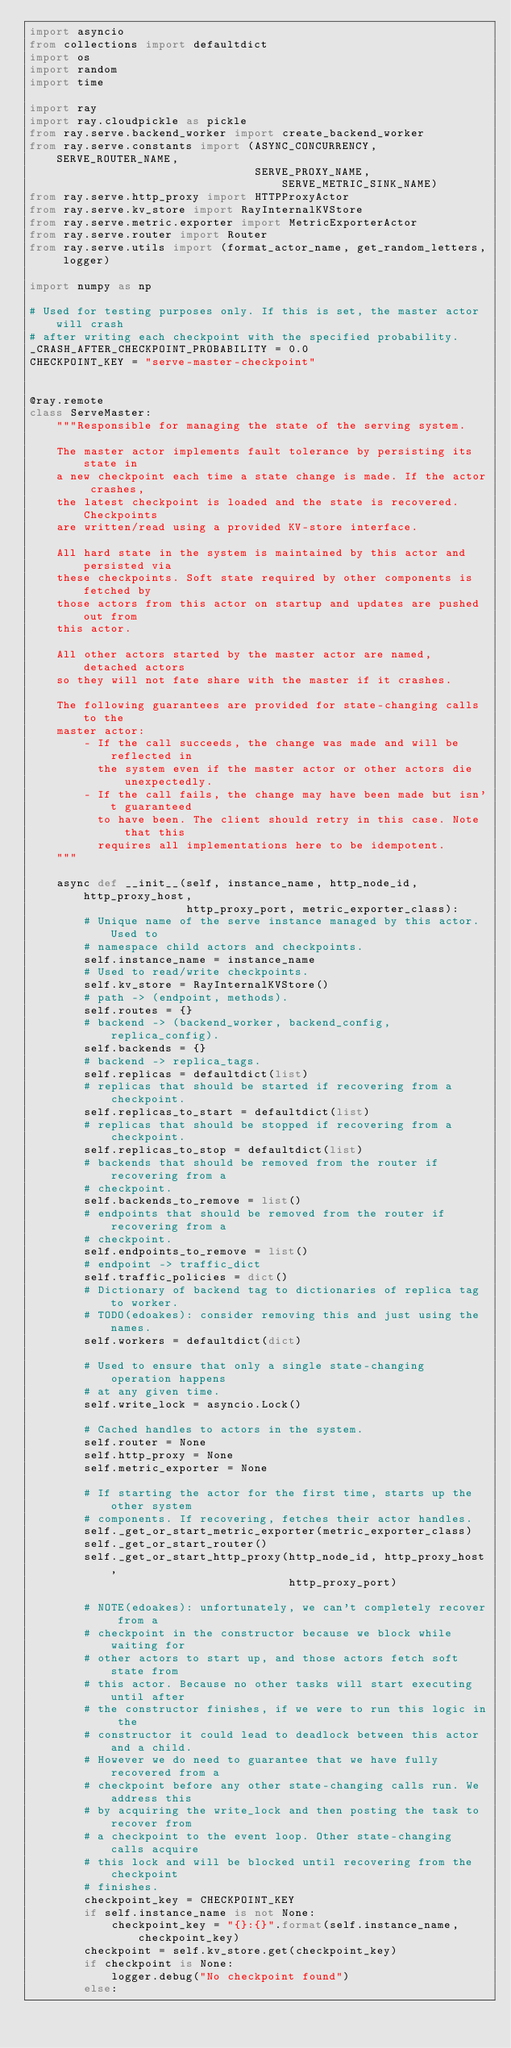Convert code to text. <code><loc_0><loc_0><loc_500><loc_500><_Python_>import asyncio
from collections import defaultdict
import os
import random
import time

import ray
import ray.cloudpickle as pickle
from ray.serve.backend_worker import create_backend_worker
from ray.serve.constants import (ASYNC_CONCURRENCY, SERVE_ROUTER_NAME,
                                 SERVE_PROXY_NAME, SERVE_METRIC_SINK_NAME)
from ray.serve.http_proxy import HTTPProxyActor
from ray.serve.kv_store import RayInternalKVStore
from ray.serve.metric.exporter import MetricExporterActor
from ray.serve.router import Router
from ray.serve.utils import (format_actor_name, get_random_letters, logger)

import numpy as np

# Used for testing purposes only. If this is set, the master actor will crash
# after writing each checkpoint with the specified probability.
_CRASH_AFTER_CHECKPOINT_PROBABILITY = 0.0
CHECKPOINT_KEY = "serve-master-checkpoint"


@ray.remote
class ServeMaster:
    """Responsible for managing the state of the serving system.

    The master actor implements fault tolerance by persisting its state in
    a new checkpoint each time a state change is made. If the actor crashes,
    the latest checkpoint is loaded and the state is recovered. Checkpoints
    are written/read using a provided KV-store interface.

    All hard state in the system is maintained by this actor and persisted via
    these checkpoints. Soft state required by other components is fetched by
    those actors from this actor on startup and updates are pushed out from
    this actor.

    All other actors started by the master actor are named, detached actors
    so they will not fate share with the master if it crashes.

    The following guarantees are provided for state-changing calls to the
    master actor:
        - If the call succeeds, the change was made and will be reflected in
          the system even if the master actor or other actors die unexpectedly.
        - If the call fails, the change may have been made but isn't guaranteed
          to have been. The client should retry in this case. Note that this
          requires all implementations here to be idempotent.
    """

    async def __init__(self, instance_name, http_node_id, http_proxy_host,
                       http_proxy_port, metric_exporter_class):
        # Unique name of the serve instance managed by this actor. Used to
        # namespace child actors and checkpoints.
        self.instance_name = instance_name
        # Used to read/write checkpoints.
        self.kv_store = RayInternalKVStore()
        # path -> (endpoint, methods).
        self.routes = {}
        # backend -> (backend_worker, backend_config, replica_config).
        self.backends = {}
        # backend -> replica_tags.
        self.replicas = defaultdict(list)
        # replicas that should be started if recovering from a checkpoint.
        self.replicas_to_start = defaultdict(list)
        # replicas that should be stopped if recovering from a checkpoint.
        self.replicas_to_stop = defaultdict(list)
        # backends that should be removed from the router if recovering from a
        # checkpoint.
        self.backends_to_remove = list()
        # endpoints that should be removed from the router if recovering from a
        # checkpoint.
        self.endpoints_to_remove = list()
        # endpoint -> traffic_dict
        self.traffic_policies = dict()
        # Dictionary of backend tag to dictionaries of replica tag to worker.
        # TODO(edoakes): consider removing this and just using the names.
        self.workers = defaultdict(dict)

        # Used to ensure that only a single state-changing operation happens
        # at any given time.
        self.write_lock = asyncio.Lock()

        # Cached handles to actors in the system.
        self.router = None
        self.http_proxy = None
        self.metric_exporter = None

        # If starting the actor for the first time, starts up the other system
        # components. If recovering, fetches their actor handles.
        self._get_or_start_metric_exporter(metric_exporter_class)
        self._get_or_start_router()
        self._get_or_start_http_proxy(http_node_id, http_proxy_host,
                                      http_proxy_port)

        # NOTE(edoakes): unfortunately, we can't completely recover from a
        # checkpoint in the constructor because we block while waiting for
        # other actors to start up, and those actors fetch soft state from
        # this actor. Because no other tasks will start executing until after
        # the constructor finishes, if we were to run this logic in the
        # constructor it could lead to deadlock between this actor and a child.
        # However we do need to guarantee that we have fully recovered from a
        # checkpoint before any other state-changing calls run. We address this
        # by acquiring the write_lock and then posting the task to recover from
        # a checkpoint to the event loop. Other state-changing calls acquire
        # this lock and will be blocked until recovering from the checkpoint
        # finishes.
        checkpoint_key = CHECKPOINT_KEY
        if self.instance_name is not None:
            checkpoint_key = "{}:{}".format(self.instance_name, checkpoint_key)
        checkpoint = self.kv_store.get(checkpoint_key)
        if checkpoint is None:
            logger.debug("No checkpoint found")
        else:</code> 